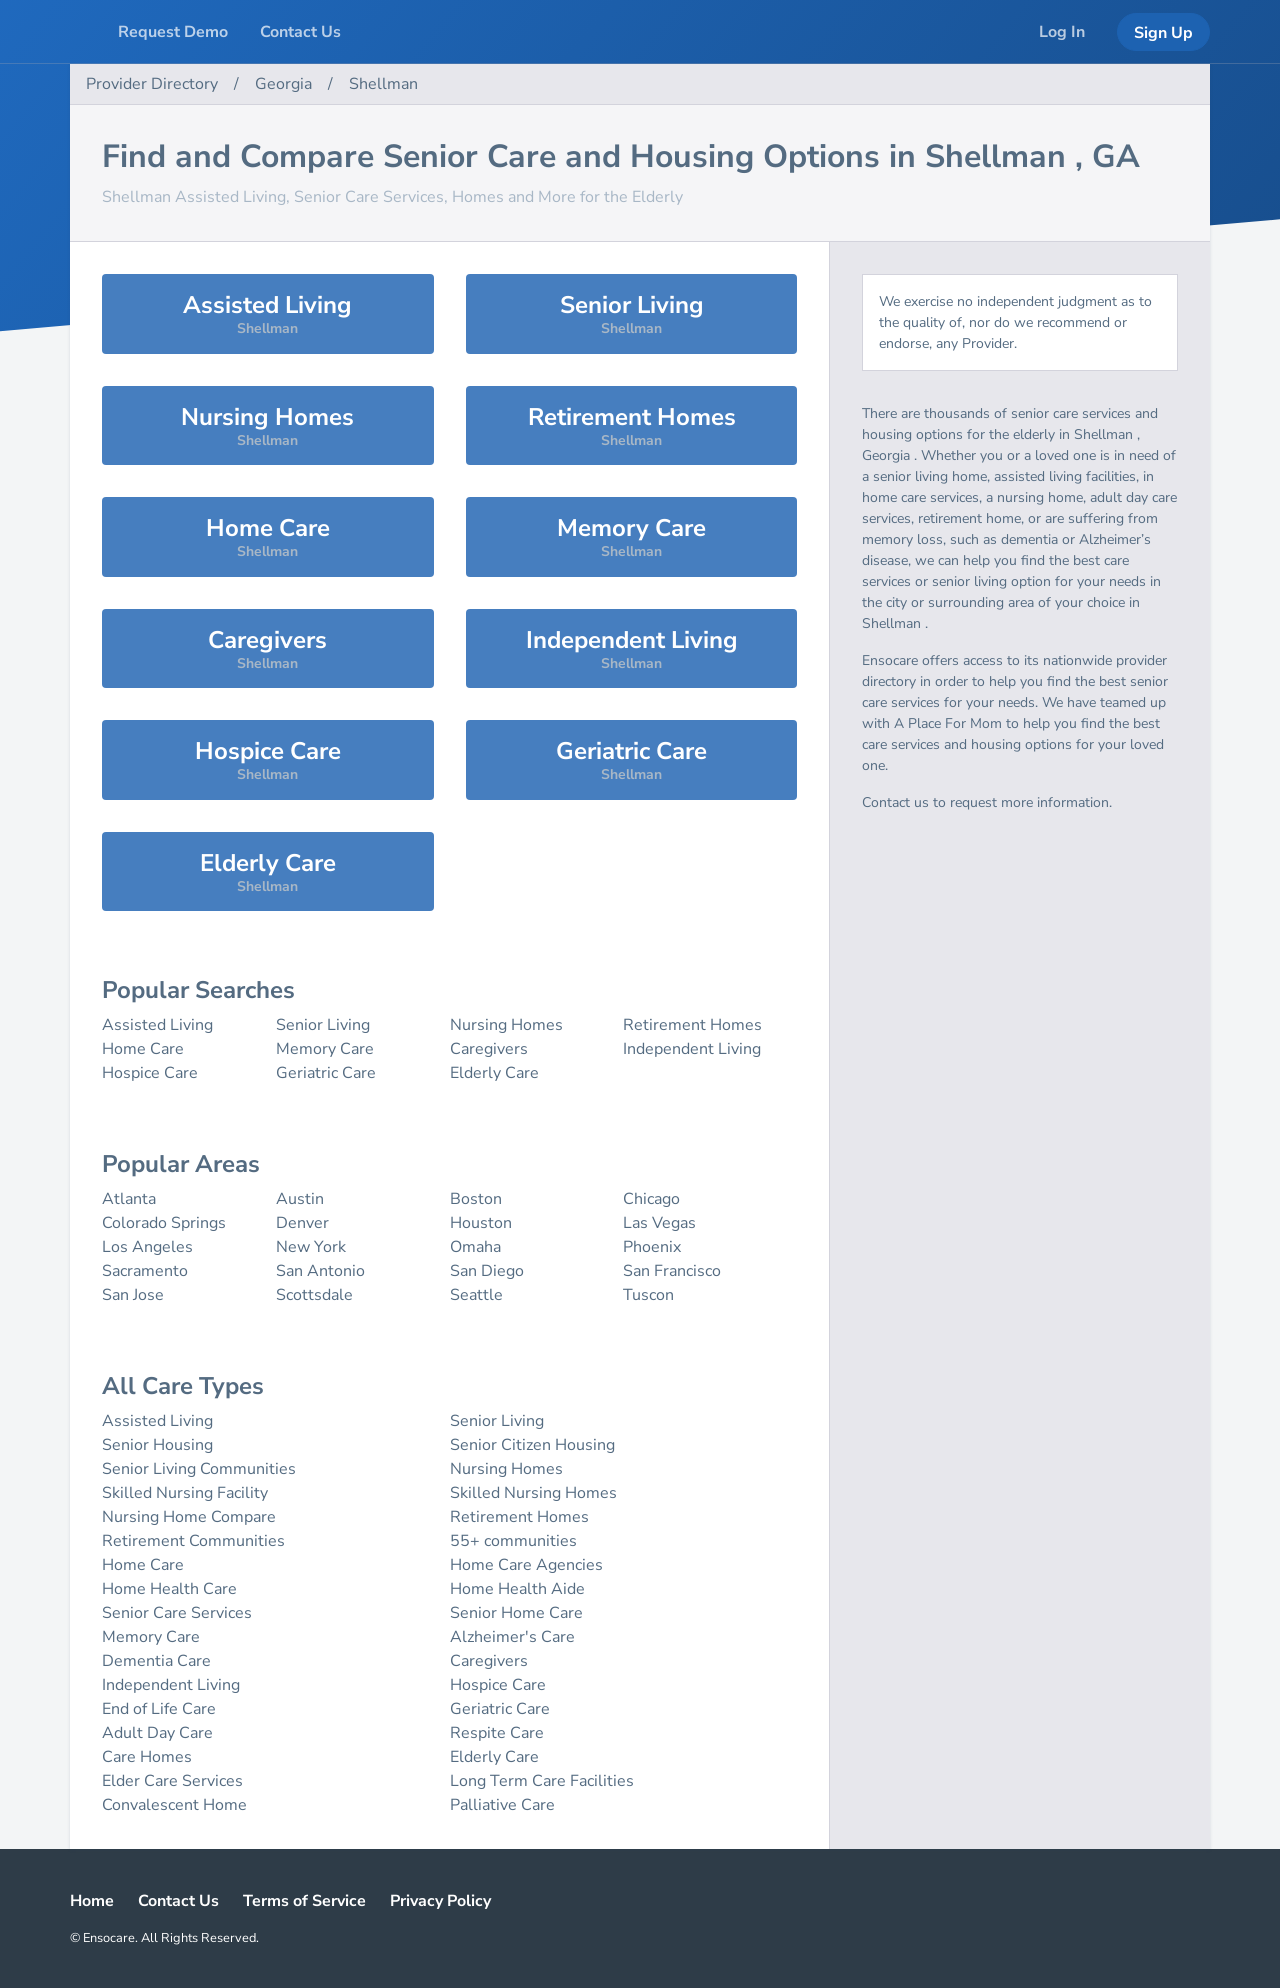Can you detail the primary services categorized under 'Senior Living' as displayed on the website? The image displays various categories under 'Senior Living' including 'Assisted Living', 'Memory Care', 'Nursing Homes', and 'Retirement Homes'. Each service offers specialized care tailored to the needs of the elderly, focusing on different levels of assistance, from residential living with minimal care to full-time medical and memory support. 